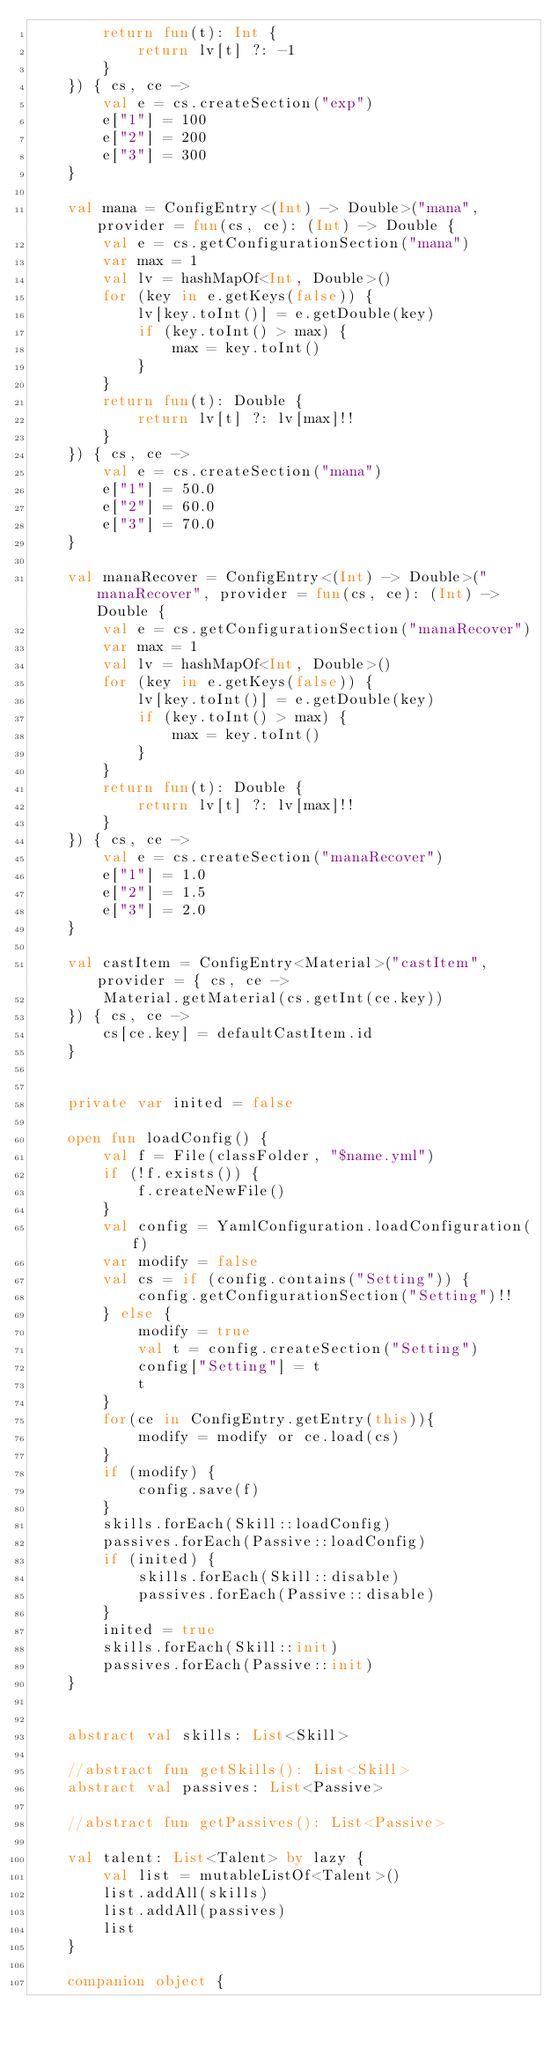<code> <loc_0><loc_0><loc_500><loc_500><_Kotlin_>        return fun(t): Int {
            return lv[t] ?: -1
        }
    }) { cs, ce ->
        val e = cs.createSection("exp")
        e["1"] = 100
        e["2"] = 200
        e["3"] = 300
    }

    val mana = ConfigEntry<(Int) -> Double>("mana", provider = fun(cs, ce): (Int) -> Double {
        val e = cs.getConfigurationSection("mana")
        var max = 1
        val lv = hashMapOf<Int, Double>()
        for (key in e.getKeys(false)) {
            lv[key.toInt()] = e.getDouble(key)
            if (key.toInt() > max) {
                max = key.toInt()
            }
        }
        return fun(t): Double {
            return lv[t] ?: lv[max]!!
        }
    }) { cs, ce ->
        val e = cs.createSection("mana")
        e["1"] = 50.0
        e["2"] = 60.0
        e["3"] = 70.0
    }

    val manaRecover = ConfigEntry<(Int) -> Double>("manaRecover", provider = fun(cs, ce): (Int) -> Double {
        val e = cs.getConfigurationSection("manaRecover")
        var max = 1
        val lv = hashMapOf<Int, Double>()
        for (key in e.getKeys(false)) {
            lv[key.toInt()] = e.getDouble(key)
            if (key.toInt() > max) {
                max = key.toInt()
            }
        }
        return fun(t): Double {
            return lv[t] ?: lv[max]!!
        }
    }) { cs, ce ->
        val e = cs.createSection("manaRecover")
        e["1"] = 1.0
        e["2"] = 1.5
        e["3"] = 2.0
    }

    val castItem = ConfigEntry<Material>("castItem", provider = { cs, ce ->
        Material.getMaterial(cs.getInt(ce.key))
    }) { cs, ce ->
        cs[ce.key] = defaultCastItem.id
    }


    private var inited = false

    open fun loadConfig() {
        val f = File(classFolder, "$name.yml")
        if (!f.exists()) {
            f.createNewFile()
        }
        val config = YamlConfiguration.loadConfiguration(f)
        var modify = false
        val cs = if (config.contains("Setting")) {
            config.getConfigurationSection("Setting")!!
        } else {
            modify = true
            val t = config.createSection("Setting")
            config["Setting"] = t
            t
        }
        for(ce in ConfigEntry.getEntry(this)){
            modify = modify or ce.load(cs)
        }
        if (modify) {
            config.save(f)
        }
        skills.forEach(Skill::loadConfig)
        passives.forEach(Passive::loadConfig)
        if (inited) {
            skills.forEach(Skill::disable)
            passives.forEach(Passive::disable)
        }
        inited = true
        skills.forEach(Skill::init)
        passives.forEach(Passive::init)
    }


    abstract val skills: List<Skill>

    //abstract fun getSkills(): List<Skill>
    abstract val passives: List<Passive>

    //abstract fun getPassives(): List<Passive>

    val talent: List<Talent> by lazy {
        val list = mutableListOf<Talent>()
        list.addAll(skills)
        list.addAll(passives)
        list
    }

    companion object {</code> 